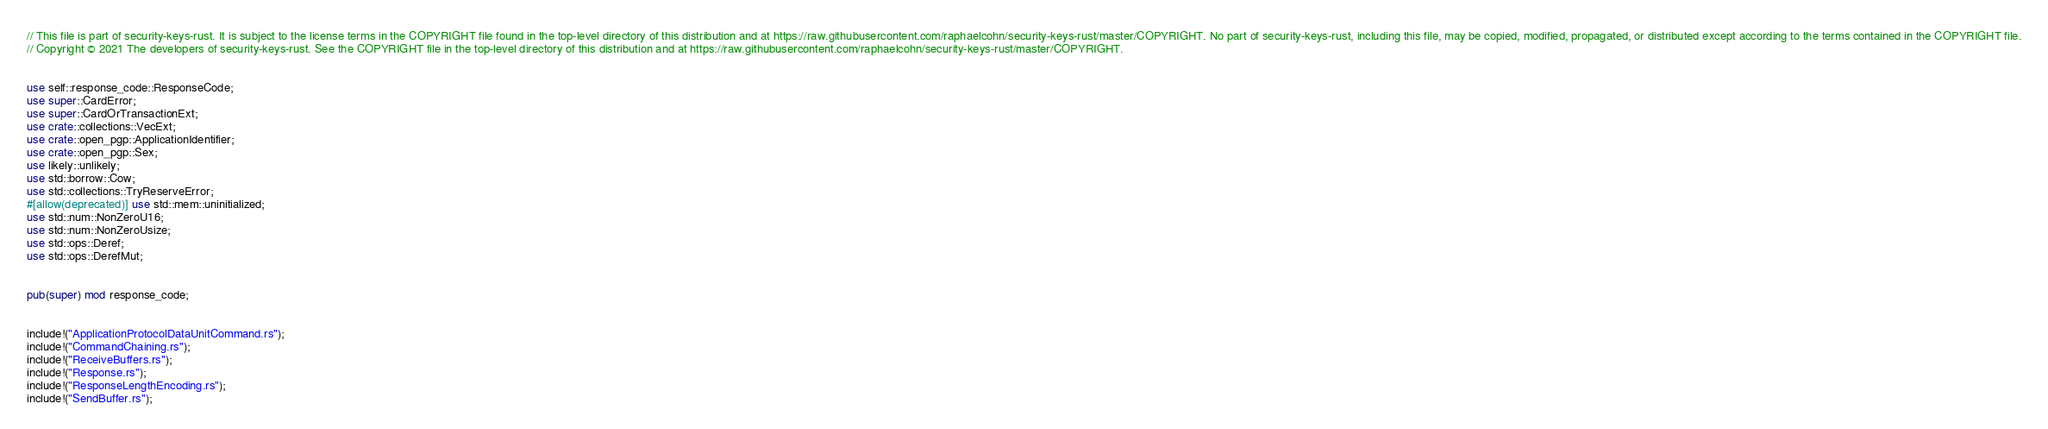Convert code to text. <code><loc_0><loc_0><loc_500><loc_500><_Rust_>// This file is part of security-keys-rust. It is subject to the license terms in the COPYRIGHT file found in the top-level directory of this distribution and at https://raw.githubusercontent.com/raphaelcohn/security-keys-rust/master/COPYRIGHT. No part of security-keys-rust, including this file, may be copied, modified, propagated, or distributed except according to the terms contained in the COPYRIGHT file.
// Copyright © 2021 The developers of security-keys-rust. See the COPYRIGHT file in the top-level directory of this distribution and at https://raw.githubusercontent.com/raphaelcohn/security-keys-rust/master/COPYRIGHT.


use self::response_code::ResponseCode;
use super::CardError;
use super::CardOrTransactionExt;
use crate::collections::VecExt;
use crate::open_pgp::ApplicationIdentifier;
use crate::open_pgp::Sex;
use likely::unlikely;
use std::borrow::Cow;
use std::collections::TryReserveError;
#[allow(deprecated)] use std::mem::uninitialized;
use std::num::NonZeroU16;
use std::num::NonZeroUsize;
use std::ops::Deref;
use std::ops::DerefMut;


pub(super) mod response_code;


include!("ApplicationProtocolDataUnitCommand.rs");
include!("CommandChaining.rs");
include!("ReceiveBuffers.rs");
include!("Response.rs");
include!("ResponseLengthEncoding.rs");
include!("SendBuffer.rs");
</code> 